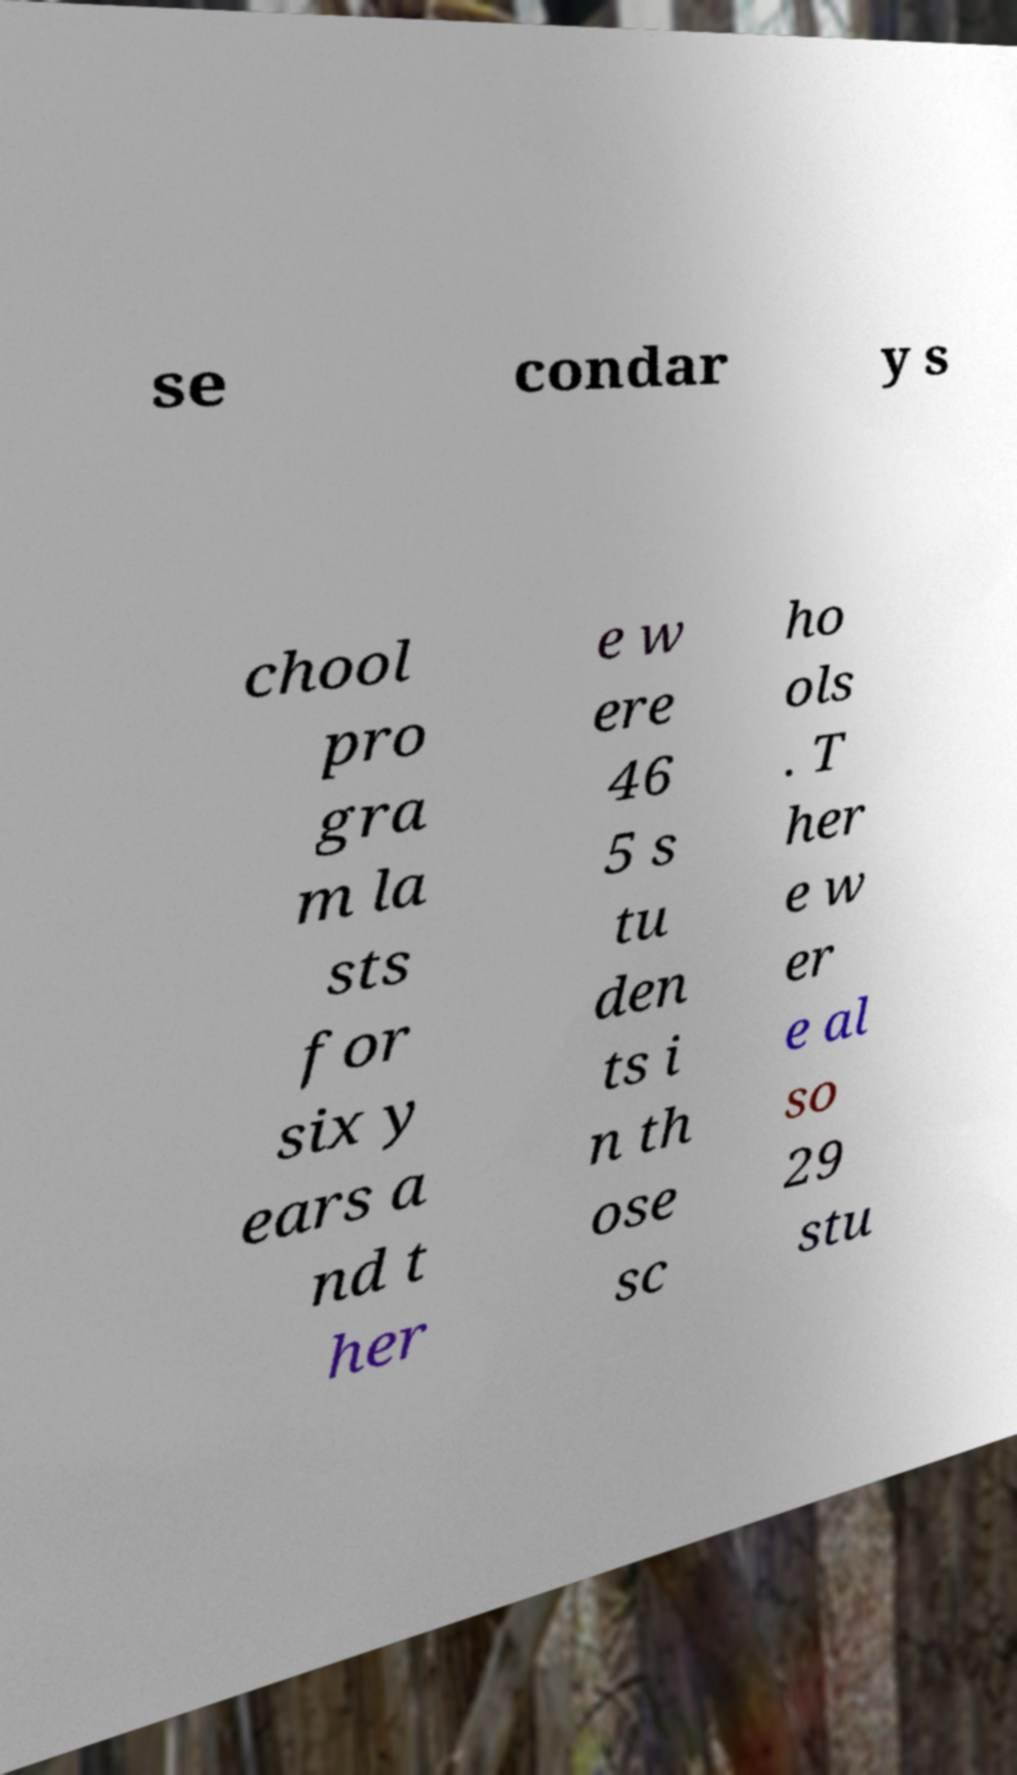Can you read and provide the text displayed in the image?This photo seems to have some interesting text. Can you extract and type it out for me? se condar y s chool pro gra m la sts for six y ears a nd t her e w ere 46 5 s tu den ts i n th ose sc ho ols . T her e w er e al so 29 stu 